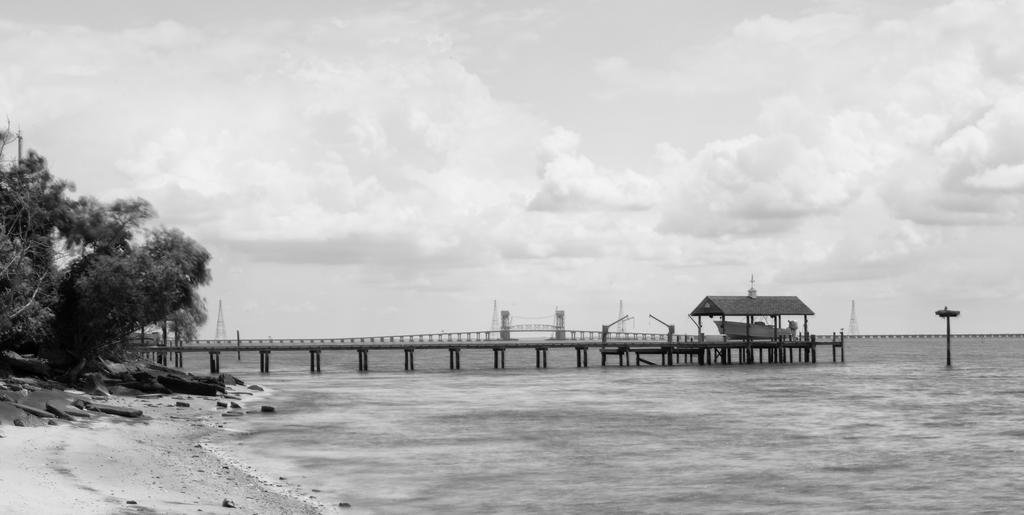In one or two sentences, can you explain what this image depicts? This picture is clicked outside. In the foreground we can see the water body and the rocks. On the left we can see the trees. In the center we can see the bridge and a gazebo and the metal rods. In the background we can see the sky which is full of clouds and we can see some other items. 